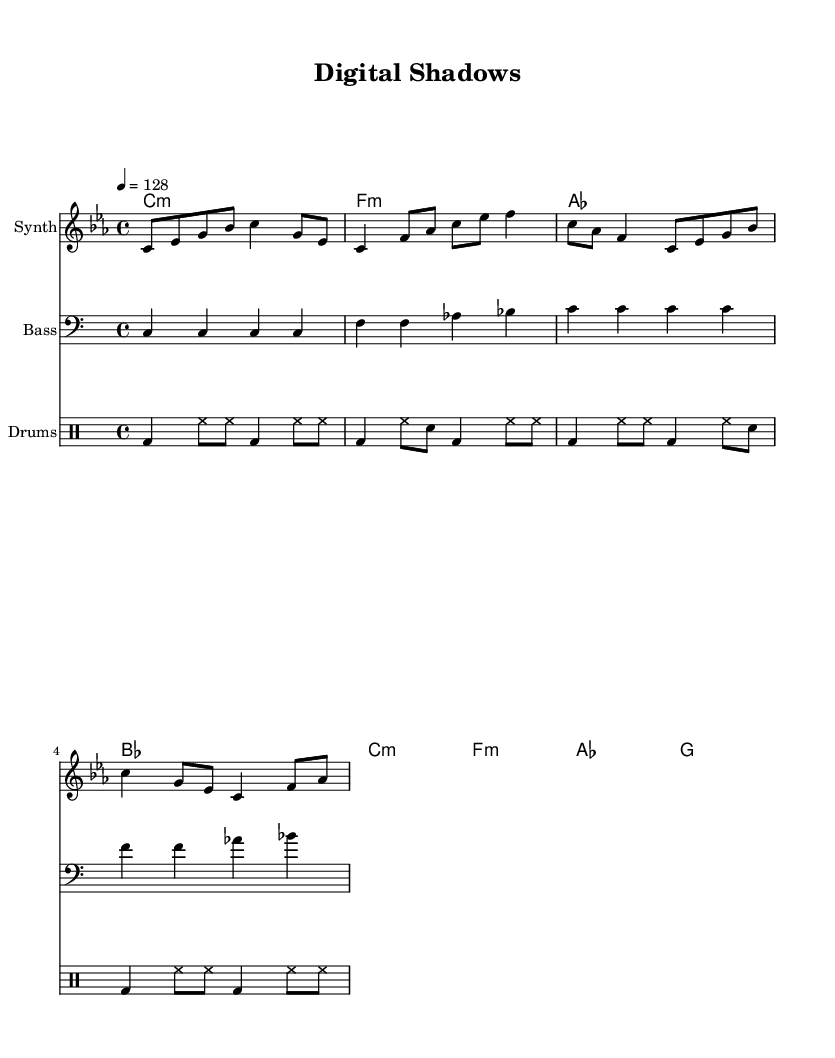What is the key signature of this music? The key signature is C minor, which has three flats (B♭, E♭, A♭).
Answer: C minor What is the time signature of this music? The time signature is indicated as 4/4, meaning there are four beats in each measure.
Answer: 4/4 What is the tempo marking for this piece? The tempo marking indicates 128 beats per minute, suggesting a moderate dance tempo typical of house music.
Answer: 128 How many measures does the melody contain? By counting the measures within the melody section, there are a total of four measures.
Answer: four Which instrument plays the bass line? The bass line is indicated to be played by an instrument named "Bass," as seen in the staff label.
Answer: Bass What is the rhythmic pattern used by the drums? The drums alternate between bass drum and hi-hat, with a pattern of bass drum hits and eighth notes for hi-hat, contributing to the house music groove.
Answer: bass and hi-hat What is the harmonic progression used in the chords? The harmonic progression consists of the following sequence: C minor, F minor, A♭, B♭, C minor, F minor, A♭, G.
Answer: C minor, F minor, A flat, B flat, C minor, F minor, A flat, G 